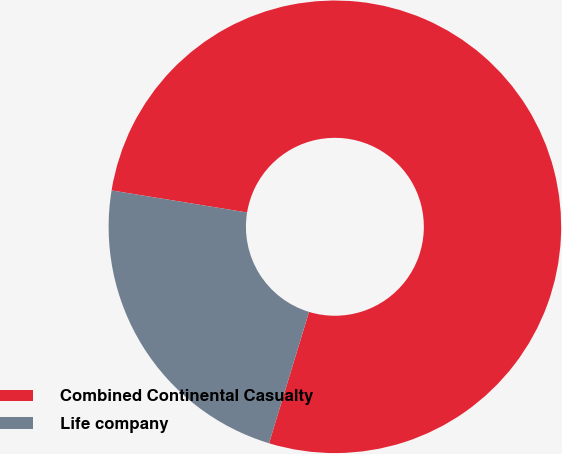Convert chart to OTSL. <chart><loc_0><loc_0><loc_500><loc_500><pie_chart><fcel>Combined Continental Casualty<fcel>Life company<nl><fcel>77.13%<fcel>22.87%<nl></chart> 